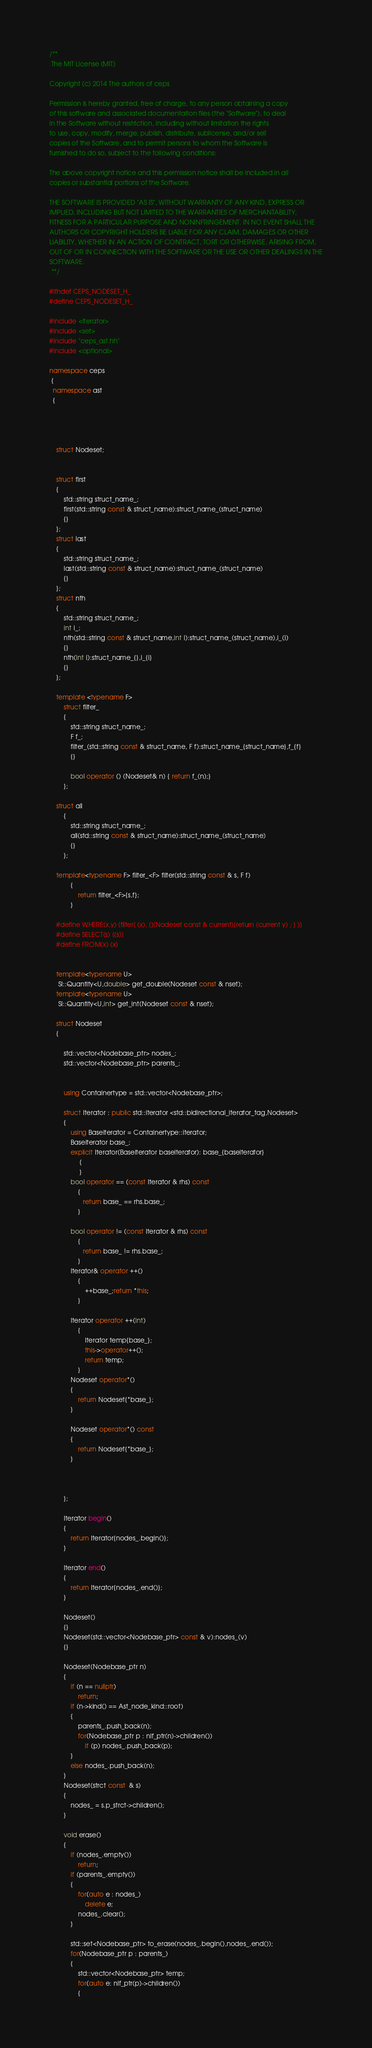Convert code to text. <code><loc_0><loc_0><loc_500><loc_500><_C++_>/**
 The MIT License (MIT)

Copyright (c) 2014 The authors of ceps

Permission is hereby granted, free of charge, to any person obtaining a copy
of this software and associated documentation files (the "Software"), to deal
in the Software without restriction, including without limitation the rights
to use, copy, modify, merge, publish, distribute, sublicense, and/or sell
copies of the Software, and to permit persons to whom the Software is
furnished to do so, subject to the following conditions:

The above copyright notice and this permission notice shall be included in all
copies or substantial portions of the Software.

THE SOFTWARE IS PROVIDED "AS IS", WITHOUT WARRANTY OF ANY KIND, EXPRESS OR
IMPLIED, INCLUDING BUT NOT LIMITED TO THE WARRANTIES OF MERCHANTABILITY,
FITNESS FOR A PARTICULAR PURPOSE AND NONINFRINGEMENT. IN NO EVENT SHALL THE
AUTHORS OR COPYRIGHT HOLDERS BE LIABLE FOR ANY CLAIM, DAMAGES OR OTHER
LIABILITY, WHETHER IN AN ACTION OF CONTRACT, TORT OR OTHERWISE, ARISING FROM,
OUT OF OR IN CONNECTION WITH THE SOFTWARE OR THE USE OR OTHER DEALINGS IN THE
SOFTWARE.
 **/

#ifndef CEPS_NODESET_H_
#define CEPS_NODESET_H_

#include <iterator>
#include <set>
#include "ceps_ast.hh"
#include <optional>

namespace ceps
 {
  namespace ast
  {
  
  
  

	struct Nodeset;
	
	
	struct first
	{
		std::string struct_name_;
		first(std::string const & struct_name):struct_name_(struct_name)
		{}
	};
	struct last
	{
		std::string struct_name_;
		last(std::string const & struct_name):struct_name_(struct_name)
		{}
	};
	struct nth
	{
		std::string struct_name_;
		int i_;
		nth(std::string const & struct_name,int i):struct_name_(struct_name),i_(i)
		{}
		nth(int i):struct_name_{},i_{i}
		{}
	};

	template <typename F>
		struct filter_
		{
			std::string struct_name_;
			F f_;
			filter_(std::string const & struct_name, F f):struct_name_{struct_name},f_{f}
			{}
	
			bool operator () (Nodeset& n) { return f_(n);}
		};
	
	struct all
		{
			std::string struct_name_;
			all(std::string const & struct_name):struct_name_(struct_name)
			{}
		};
	
	template<typename F> filter_<F> filter(std::string const & s, F f)
			{
				return filter_<F>{s,f};
			}
	
	#define WHERE(x,y) [filter( (x), [](Nodeset const & current){return (current y) ; } )]
	#define SELECT(s) [(s)]
	#define FROM(x) (x)
	
	
	template<typename U>
	 SI::Quantity<U,double> get_double(Nodeset const & nset);
	template<typename U>
	 SI::Quantity<U,int> get_int(Nodeset const & nset);
	
	struct Nodeset
	{
	
		std::vector<Nodebase_ptr> nodes_;
		std::vector<Nodebase_ptr> parents_;


		using Containertype = std::vector<Nodebase_ptr>;
		
		struct Iterator : public std::iterator <std::bidirectional_iterator_tag,Nodeset>
		{
			using Baseiterator = Containertype::iterator;
			Baseiterator base_;
			explicit Iterator(Baseiterator baseiterator): base_{baseiterator}
				 {
				 }
			bool operator == (const Iterator & rhs) const
				{
				   return base_ == rhs.base_;
				}

			bool operator != (const Iterator & rhs) const
				{
				   return base_ != rhs.base_;
				}
			Iterator& operator ++()
				{
					++base_;return *this;
				}

			Iterator operator ++(int)
				{
					Iterator temp{base_};
					this->operator++();
					return temp;
				}
			Nodeset operator*()
			{
				return Nodeset{*base_};
			}

			Nodeset operator*() const
			{
				return Nodeset{*base_};
			}


			
		};
		
		Iterator begin()
		{
			return Iterator{nodes_.begin()};			
		}

		Iterator end()
		{
			return Iterator{nodes_.end()};			
		}
		
		Nodeset()
		{}
		Nodeset(std::vector<Nodebase_ptr> const & v):nodes_(v)
		{}
	
		Nodeset(Nodebase_ptr n)
		{
			if (n == nullptr)
				return;
			if (n->kind() == Ast_node_kind::root)
			{
				parents_.push_back(n);
				for(Nodebase_ptr p : nlf_ptr(n)->children())
					if (p) nodes_.push_back(p);
			}
			else nodes_.push_back(n);
		}
		Nodeset(strct const  & s)
		{
			nodes_ = s.p_strct->children();
		}

		void erase()
		{
			if (nodes_.empty())
				return;
			if (parents_.empty())
			{
				for(auto e : nodes_)
					delete e;
				nodes_.clear();
			}

			std::set<Nodebase_ptr> to_erase(nodes_.begin(),nodes_.end());
			for(Nodebase_ptr p : parents_)
			{
				std::vector<Nodebase_ptr> temp;
				for(auto e: nlf_ptr(p)->children())
				{</code> 